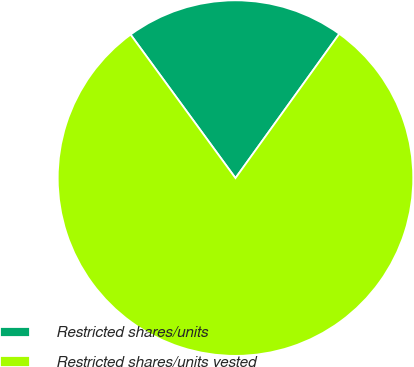Convert chart to OTSL. <chart><loc_0><loc_0><loc_500><loc_500><pie_chart><fcel>Restricted shares/units<fcel>Restricted shares/units vested<nl><fcel>19.97%<fcel>80.03%<nl></chart> 